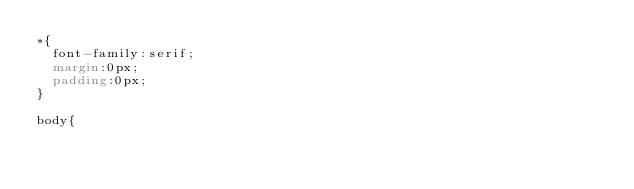<code> <loc_0><loc_0><loc_500><loc_500><_CSS_>*{
  font-family:serif;
  margin:0px;
  padding:0px;
}

body{</code> 